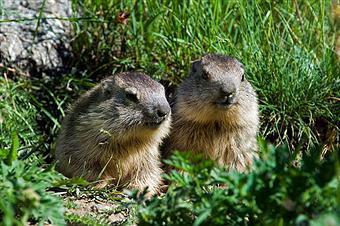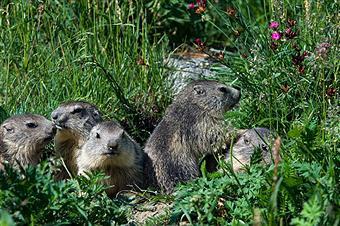The first image is the image on the left, the second image is the image on the right. Evaluate the accuracy of this statement regarding the images: "In each image, there are at least two animals.". Is it true? Answer yes or no. Yes. The first image is the image on the left, the second image is the image on the right. Examine the images to the left and right. Is the description "At least one image contains 3 or more animals." accurate? Answer yes or no. Yes. 